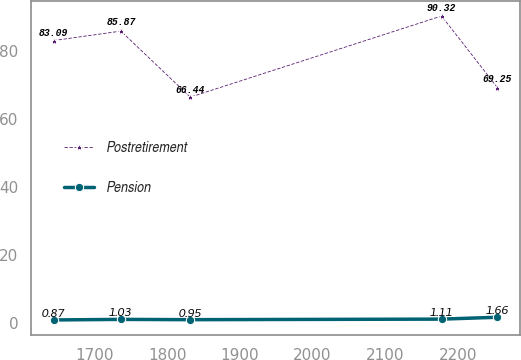Convert chart. <chart><loc_0><loc_0><loc_500><loc_500><line_chart><ecel><fcel>Postretirement<fcel>Pension<nl><fcel>1643.9<fcel>83.09<fcel>0.87<nl><fcel>1736.44<fcel>85.87<fcel>1.03<nl><fcel>1831.93<fcel>66.44<fcel>0.95<nl><fcel>2177.62<fcel>90.32<fcel>1.11<nl><fcel>2254.47<fcel>69.25<fcel>1.66<nl></chart> 